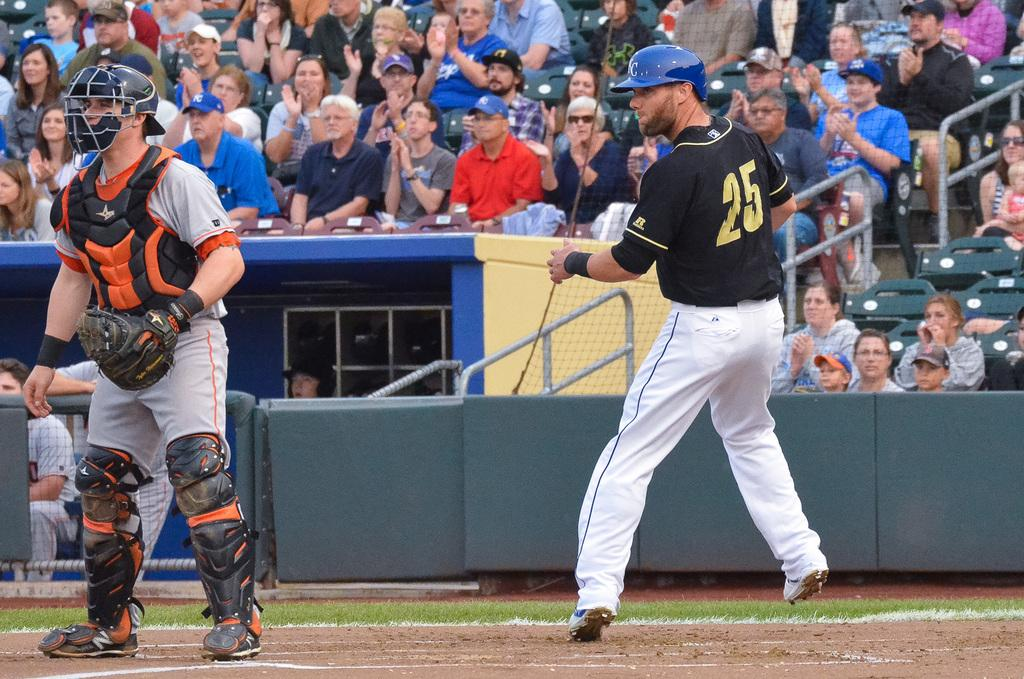Provide a one-sentence caption for the provided image. The player batting is wearing the number 25. 